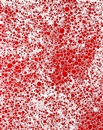Can you suggest what emotions or ideas this artwork might evoke in a viewer? The intense burst of red surrounded by a field of soft white dots could evoke feelings of passion or intensity. It might also inspire awe or curiosity, as the pattern might mimic astronomical phenomena or natural occurrences like blooming flowers or a fiery explosion. This artwork leaves plenty open to emotional and intellectual interpretation. 